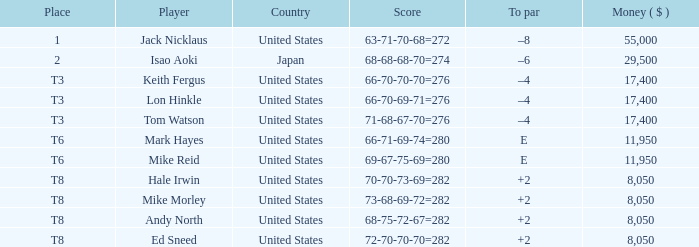What country has the score og 66-70-69-71=276? United States. 